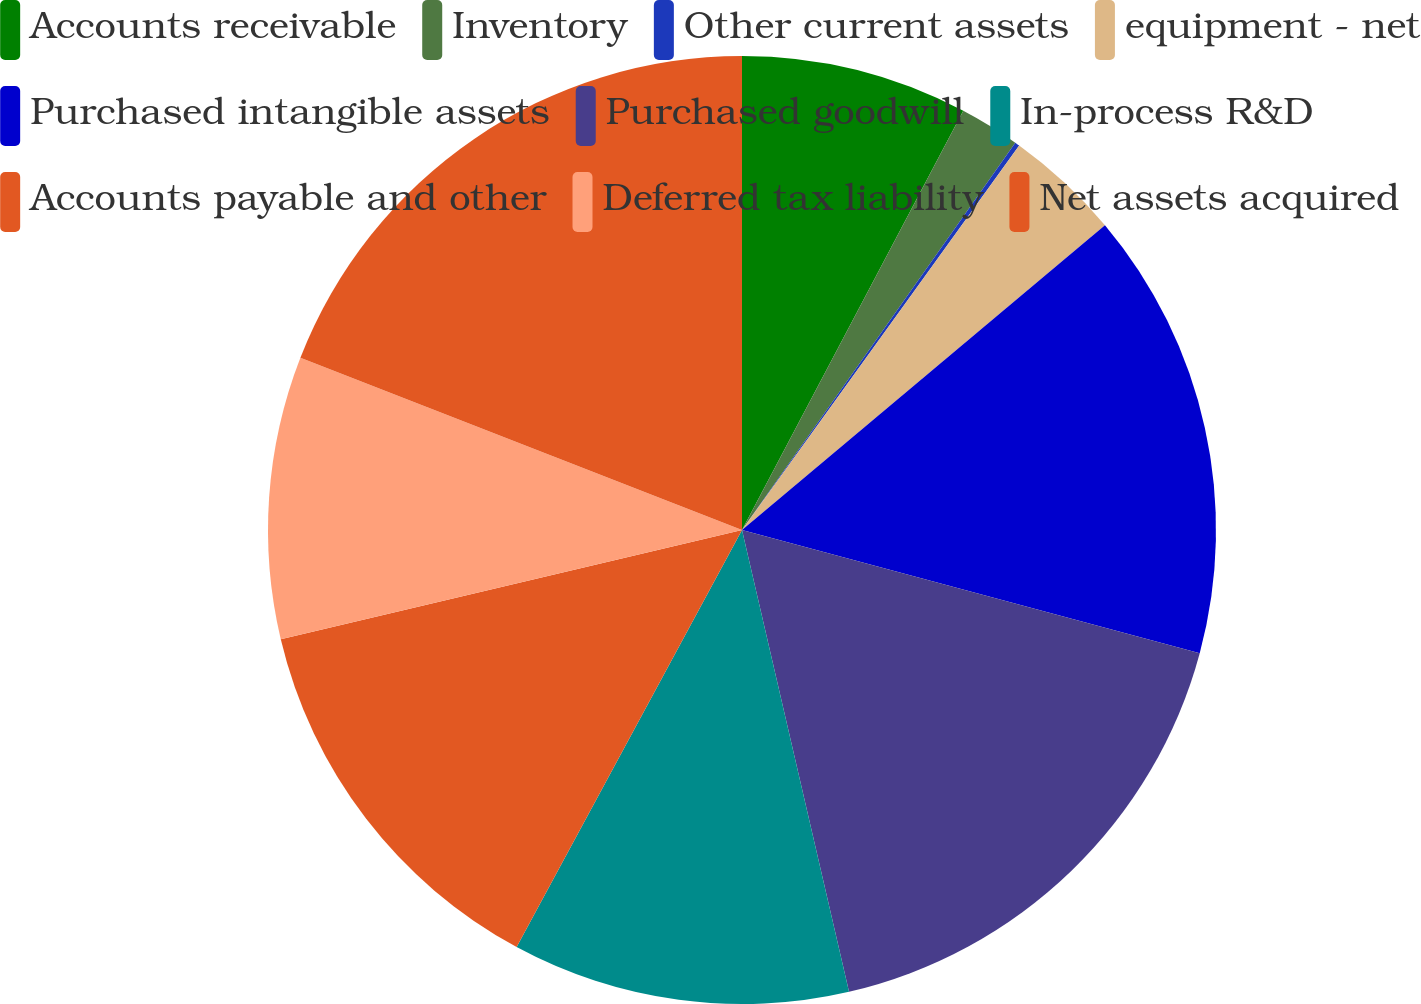<chart> <loc_0><loc_0><loc_500><loc_500><pie_chart><fcel>Accounts receivable<fcel>Inventory<fcel>Other current assets<fcel>equipment - net<fcel>Purchased intangible assets<fcel>Purchased goodwill<fcel>In-process R&D<fcel>Accounts payable and other<fcel>Deferred tax liability<fcel>Net assets acquired<nl><fcel>7.73%<fcel>2.05%<fcel>0.16%<fcel>3.94%<fcel>15.3%<fcel>17.19%<fcel>11.51%<fcel>13.41%<fcel>9.62%<fcel>19.08%<nl></chart> 